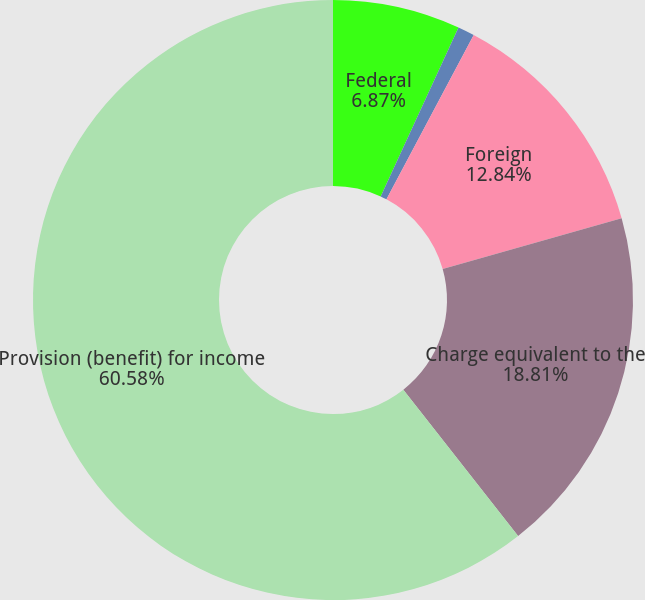<chart> <loc_0><loc_0><loc_500><loc_500><pie_chart><fcel>Federal<fcel>State<fcel>Foreign<fcel>Charge equivalent to the<fcel>Provision (benefit) for income<nl><fcel>6.87%<fcel>0.9%<fcel>12.84%<fcel>18.81%<fcel>60.59%<nl></chart> 